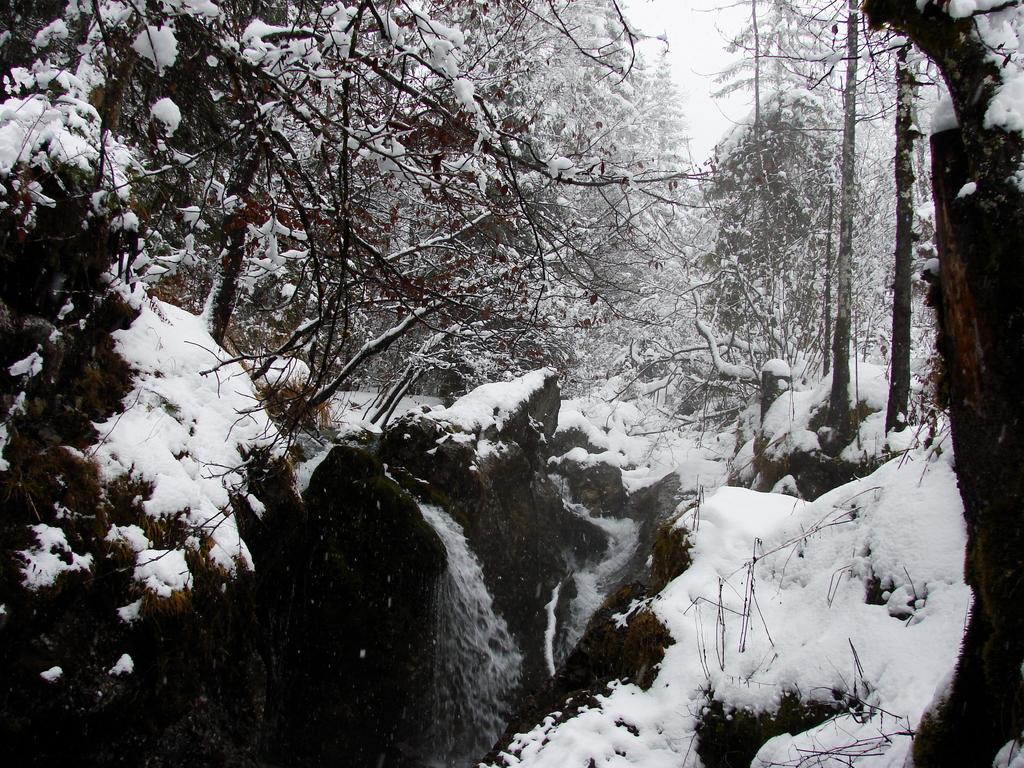What type of vegetation is visible in the image? There are trees in the image. What is the weather condition in the image? There is snow in the image, suggesting a cold or wintery environment. What is visible in the sky in the image? The sky is visible in the image. What is the color scheme of the image? The image is black and white in color. Where is the nearest hospital in the image? There is no reference to a hospital in the image, so it is not possible to determine its location. What type of pies are being baked in the image? There is no indication of any pies or baking activity in the image. 